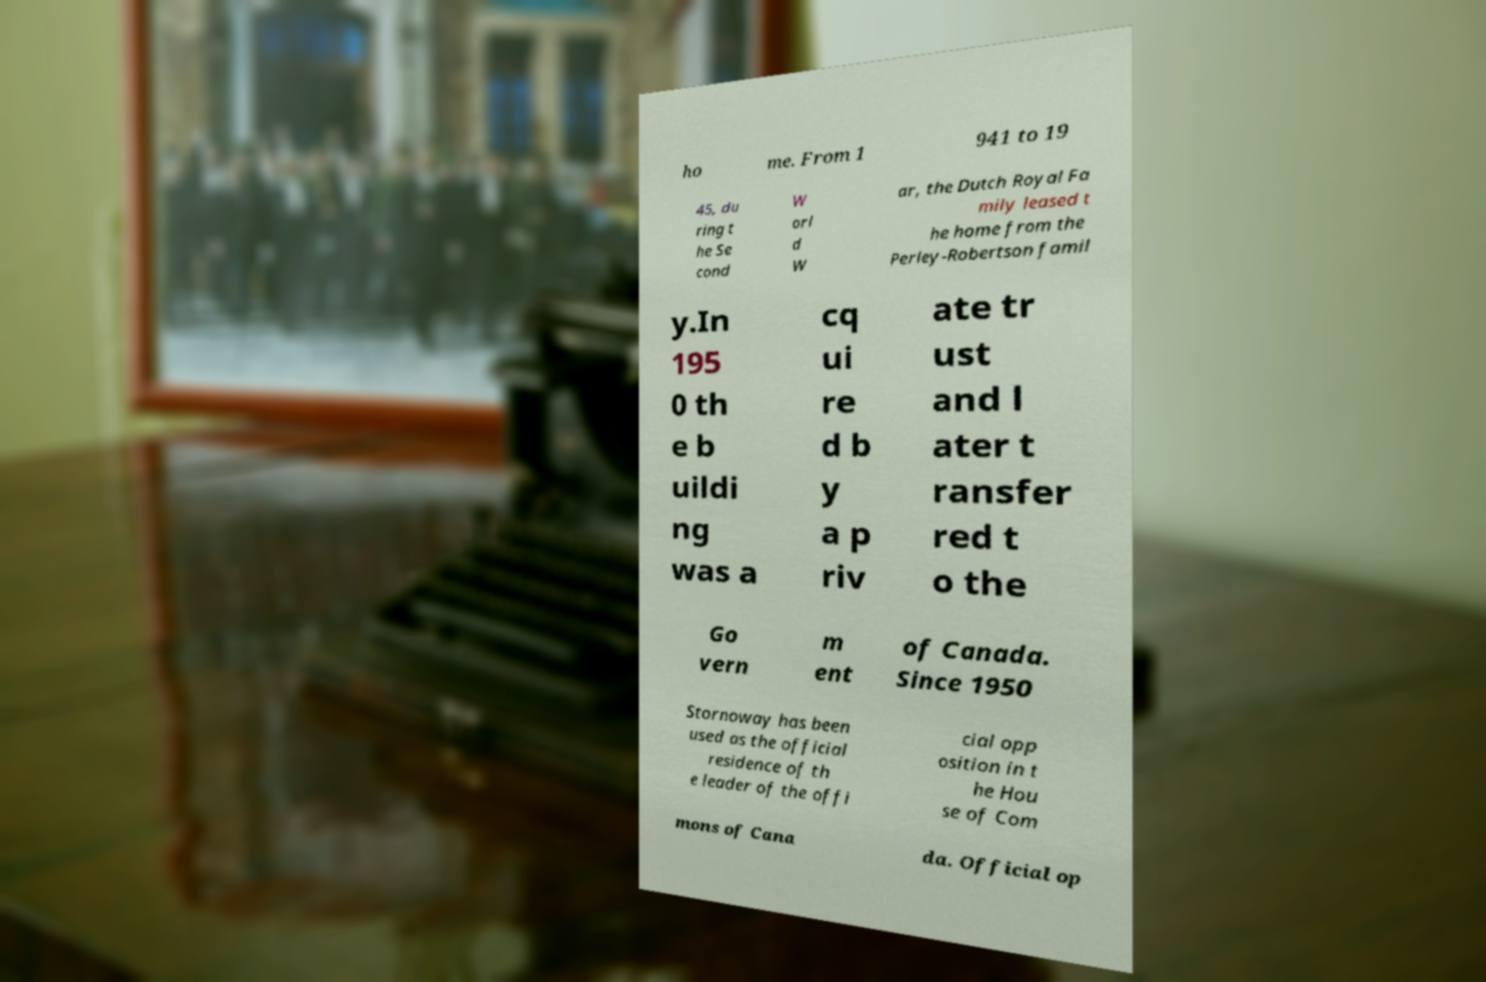For documentation purposes, I need the text within this image transcribed. Could you provide that? ho me. From 1 941 to 19 45, du ring t he Se cond W orl d W ar, the Dutch Royal Fa mily leased t he home from the Perley-Robertson famil y.In 195 0 th e b uildi ng was a cq ui re d b y a p riv ate tr ust and l ater t ransfer red t o the Go vern m ent of Canada. Since 1950 Stornoway has been used as the official residence of th e leader of the offi cial opp osition in t he Hou se of Com mons of Cana da. Official op 